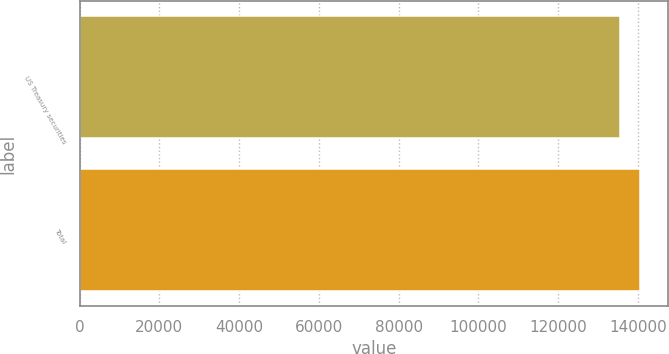<chart> <loc_0><loc_0><loc_500><loc_500><bar_chart><fcel>US Treasury securities<fcel>Total<nl><fcel>135492<fcel>140490<nl></chart> 